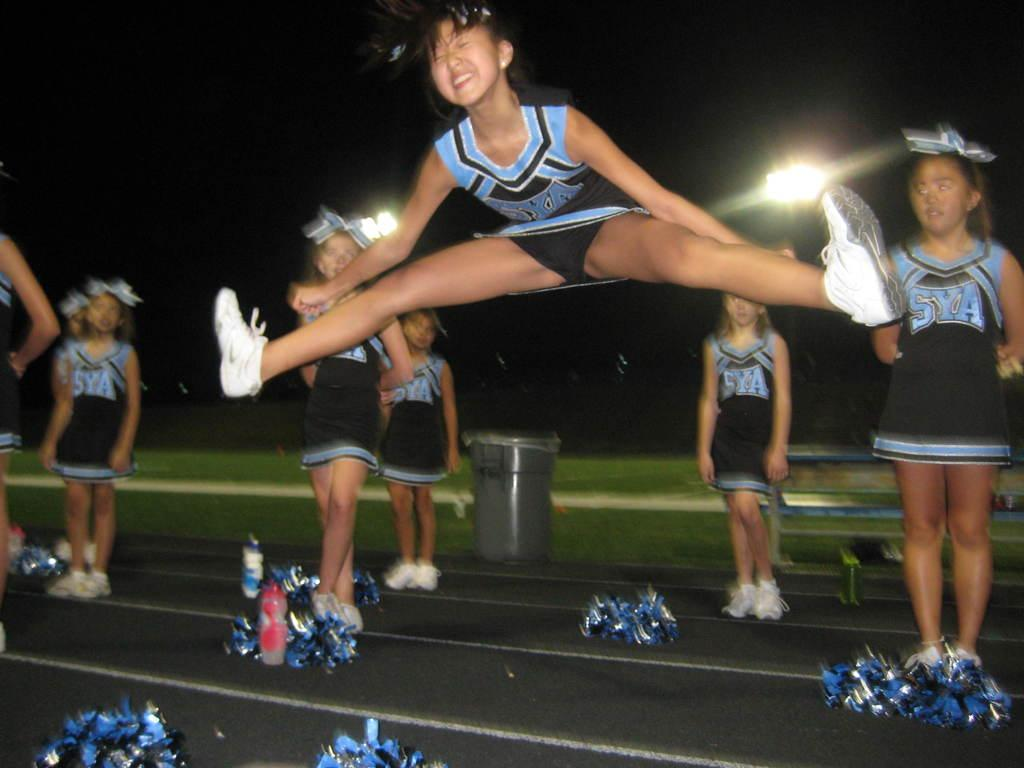<image>
Offer a succinct explanation of the picture presented. SYA is the team name shown on these cheerleader's outfits. 